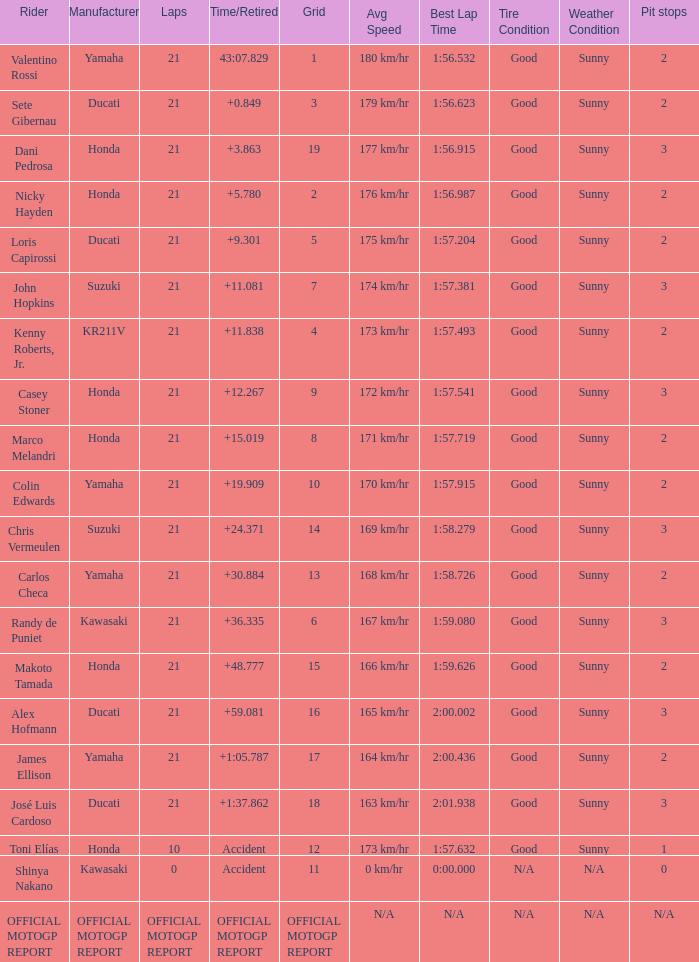When rider John Hopkins had 21 laps, what was the grid? 7.0. 